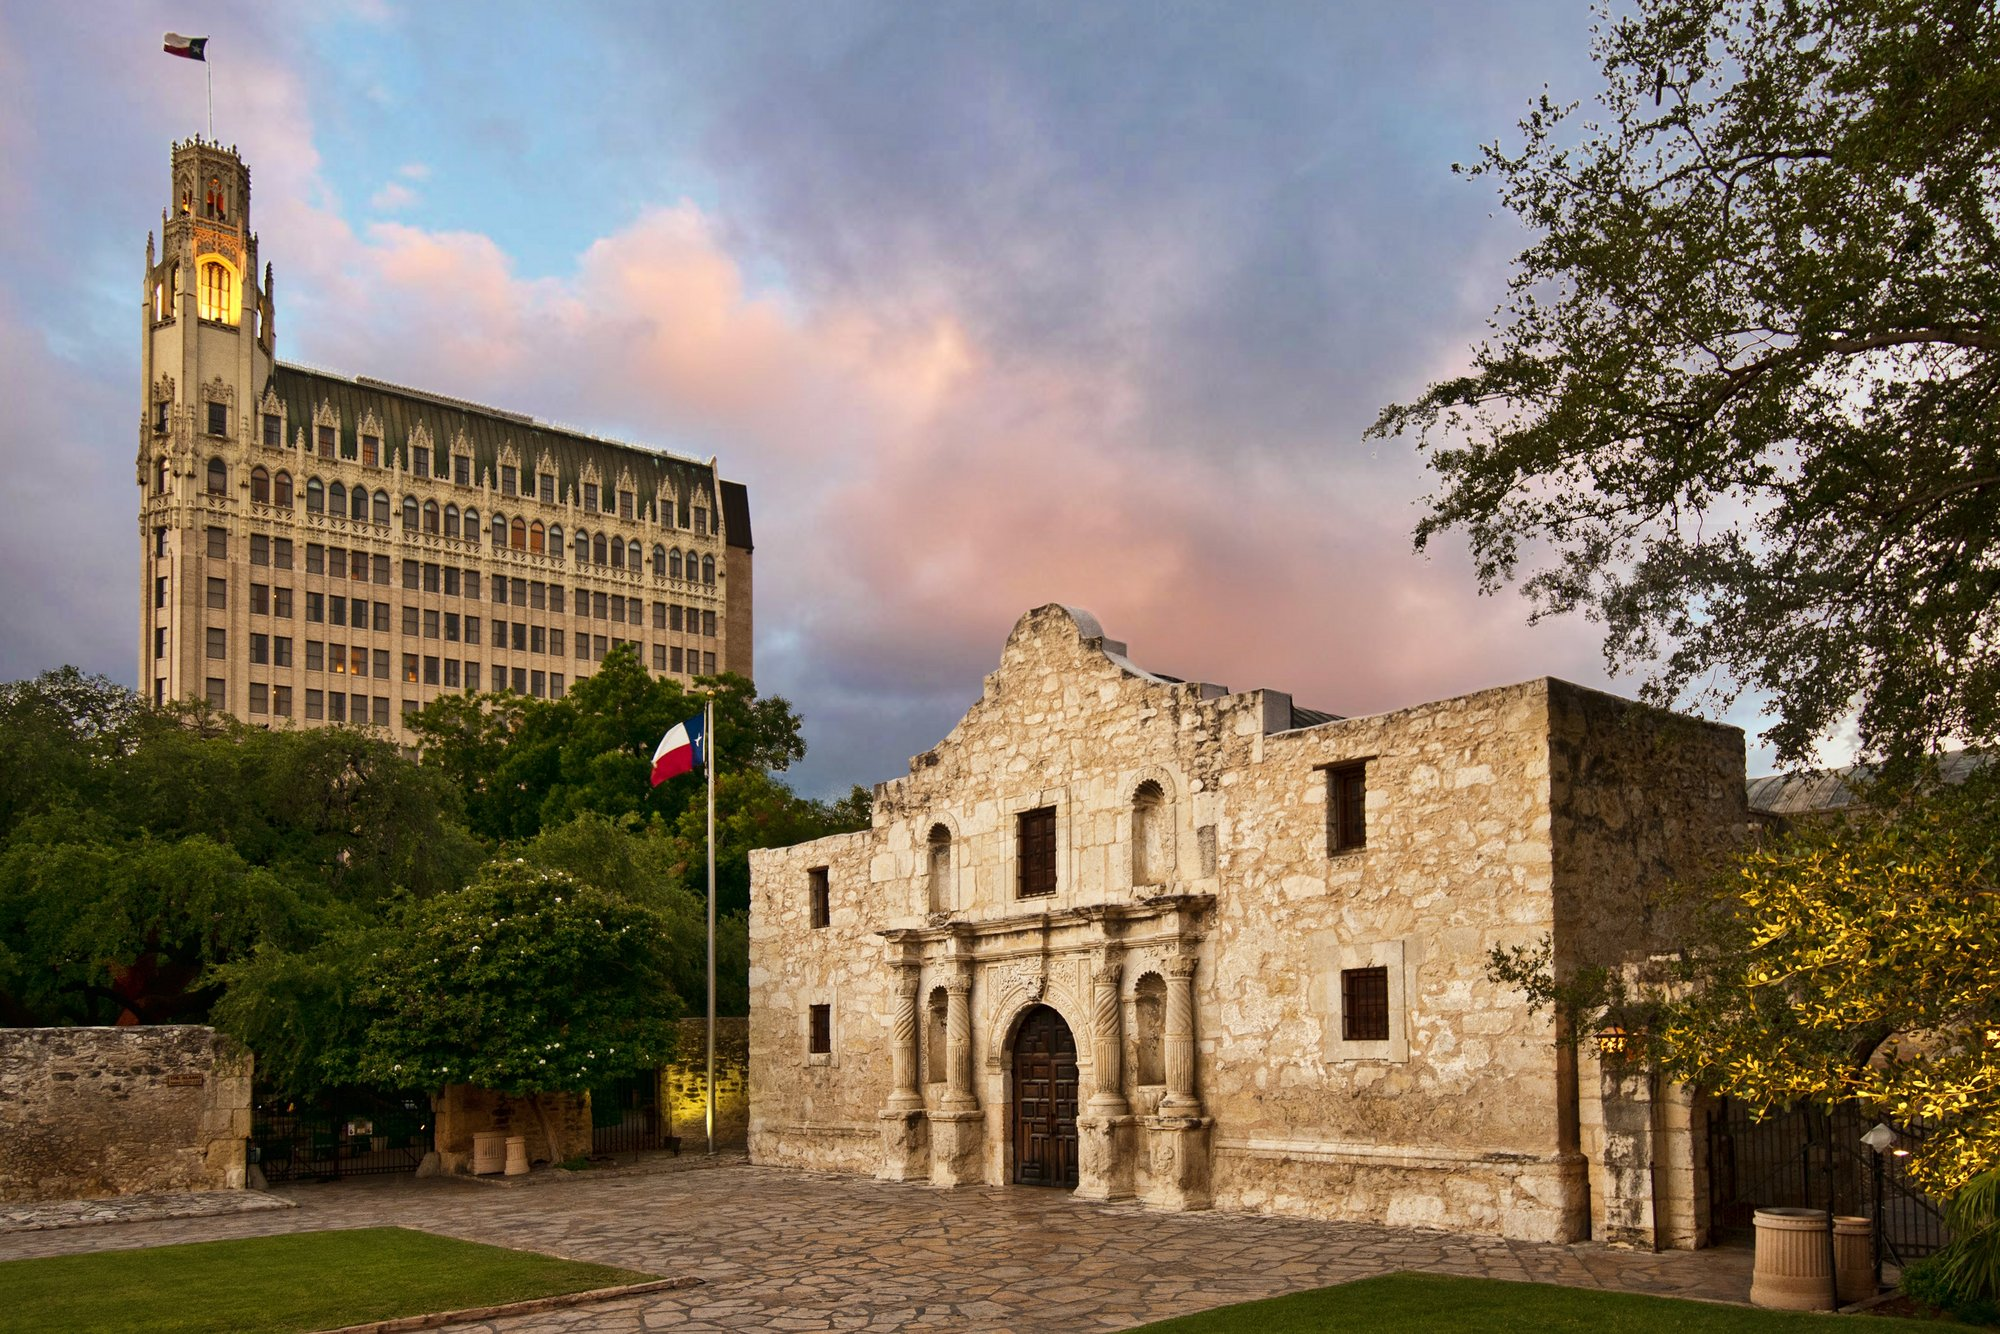What kind of scenarios could be envisioned around this location in the past? One could envision a bustling scene in the early 1800s, with people going about their daily lives in what was then a mission. Soldiers and civilians are seen moving in and out of the Alamo, the air filled with the sounds of horse hooves and the occasional gunshot in the distance. The ground is dusty, and carts laden with goods line the streets. Inside, missionaries and native converts go about their tasks, preparing for the day. The Alamo appears as a hive of activity, a focal point of defense and community. In contrast, a quieter, somber scene could take place following the Battle of the Alamo in 1836, with the structure standing witness to the aftermath of the fierce conflict that took place within its walls. 